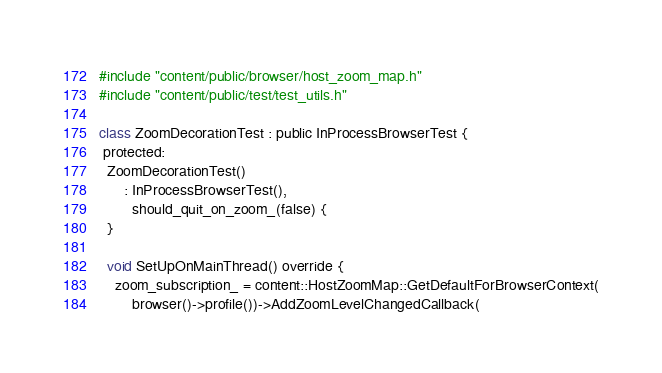Convert code to text. <code><loc_0><loc_0><loc_500><loc_500><_ObjectiveC_>#include "content/public/browser/host_zoom_map.h"
#include "content/public/test/test_utils.h"

class ZoomDecorationTest : public InProcessBrowserTest {
 protected:
  ZoomDecorationTest()
      : InProcessBrowserTest(),
        should_quit_on_zoom_(false) {
  }

  void SetUpOnMainThread() override {
    zoom_subscription_ = content::HostZoomMap::GetDefaultForBrowserContext(
        browser()->profile())->AddZoomLevelChangedCallback(</code> 